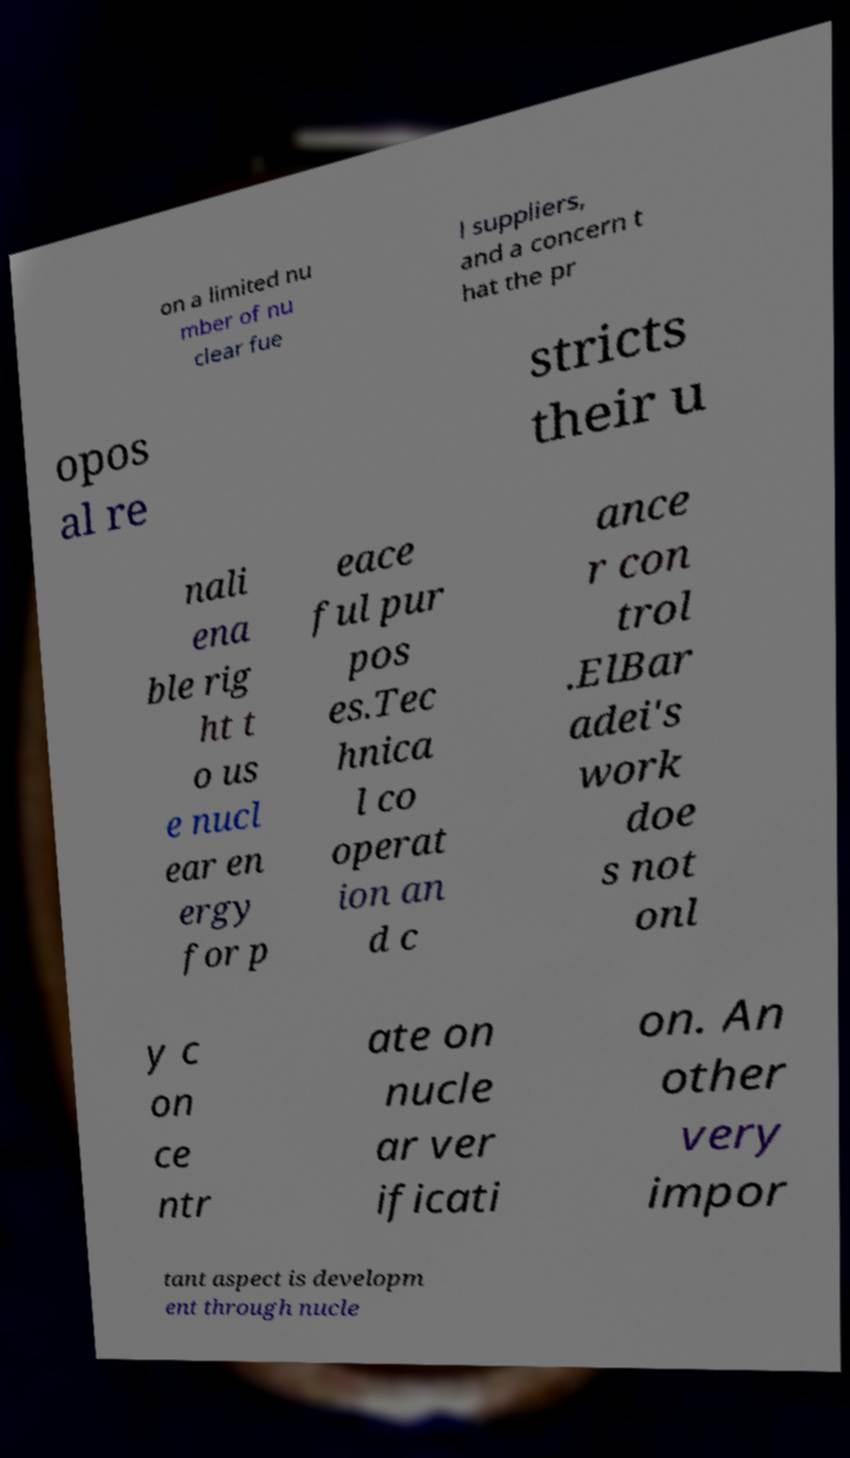Can you accurately transcribe the text from the provided image for me? on a limited nu mber of nu clear fue l suppliers, and a concern t hat the pr opos al re stricts their u nali ena ble rig ht t o us e nucl ear en ergy for p eace ful pur pos es.Tec hnica l co operat ion an d c ance r con trol .ElBar adei's work doe s not onl y c on ce ntr ate on nucle ar ver ificati on. An other very impor tant aspect is developm ent through nucle 